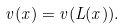Convert formula to latex. <formula><loc_0><loc_0><loc_500><loc_500>v ( x ) = v ( L ( x ) ) .</formula> 